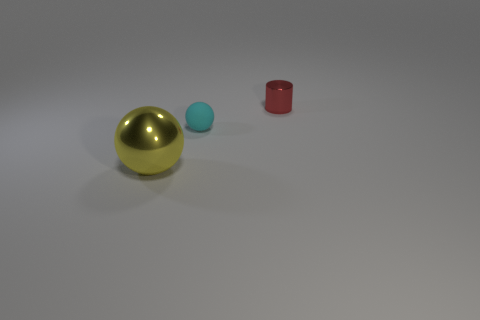Add 3 big yellow spheres. How many objects exist? 6 Subtract all balls. How many objects are left? 1 Add 2 spheres. How many spheres exist? 4 Subtract 0 yellow blocks. How many objects are left? 3 Subtract all tiny cylinders. Subtract all small cyan rubber things. How many objects are left? 1 Add 2 tiny cyan spheres. How many tiny cyan spheres are left? 3 